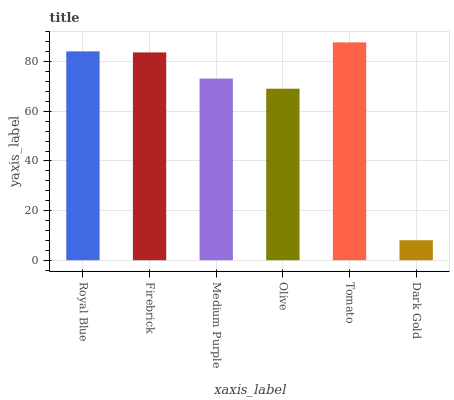Is Dark Gold the minimum?
Answer yes or no. Yes. Is Tomato the maximum?
Answer yes or no. Yes. Is Firebrick the minimum?
Answer yes or no. No. Is Firebrick the maximum?
Answer yes or no. No. Is Royal Blue greater than Firebrick?
Answer yes or no. Yes. Is Firebrick less than Royal Blue?
Answer yes or no. Yes. Is Firebrick greater than Royal Blue?
Answer yes or no. No. Is Royal Blue less than Firebrick?
Answer yes or no. No. Is Firebrick the high median?
Answer yes or no. Yes. Is Medium Purple the low median?
Answer yes or no. Yes. Is Medium Purple the high median?
Answer yes or no. No. Is Firebrick the low median?
Answer yes or no. No. 